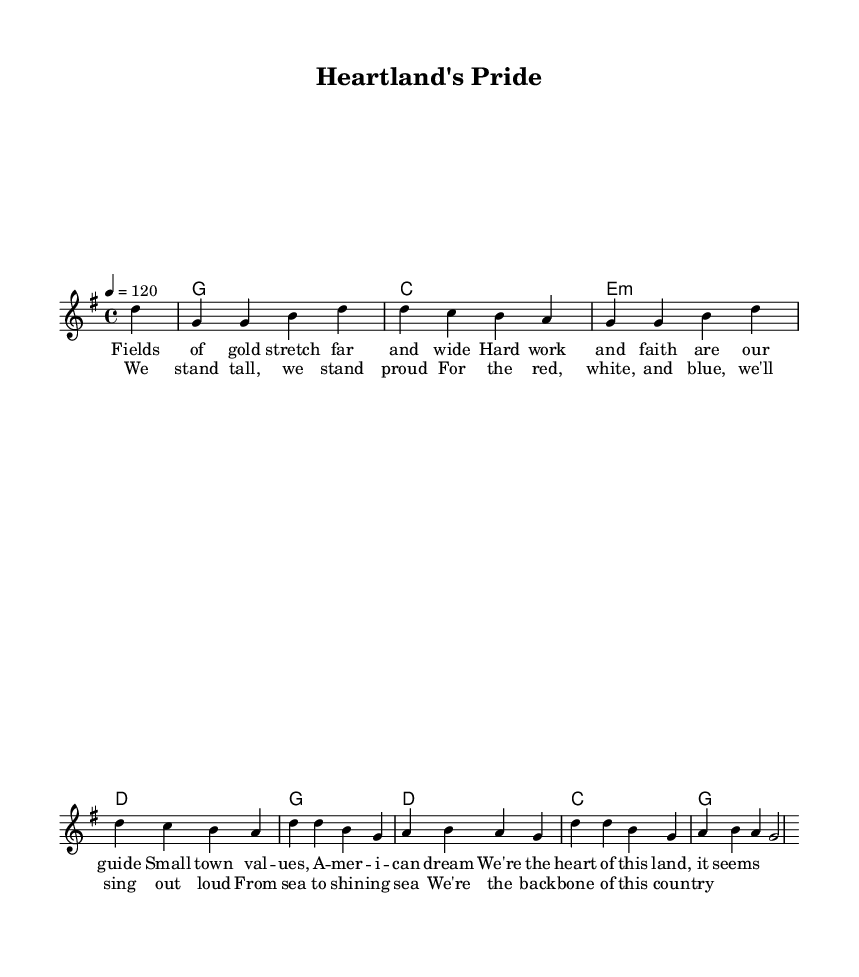What is the key signature of this music? The key signature displayed in the music is G major, which contains one sharp (F#). This is indicated at the beginning of the staff with a sign showing the sharp.
Answer: G major What is the time signature of this piece? The time signature is indicated at the beginning of the score as 4/4, meaning there are four beats per measure, and the quarter note receives one beat.
Answer: 4/4 What is the tempo marking for this song? The tempo marking is shown as 4 = 120, indicating that there are 120 quarter note beats per minute, leading to a moderately fast pace.
Answer: 120 How many measures are in the verse section of this piece? Counting each group of notes and the separation of lyrics, there are a total of 4 measures in the verse section of the music.
Answer: 4 What is the first lyric line in the chorus? The first line of lyrics in the chorus is located after the word "chorus," showing the text that follows it. That line reads: "We stand tall, we stand proud".
Answer: We stand tall, we stand proud Which chord accompanies the first measure of the melody? The first measure of the melody is accompanied by the chord G, which is indicated in the chord mode section of the score.
Answer: G What values do the lyrics emphasize in the verse? The lyrics emphasize values such as hard work, faith, and small-town values, highlighting the essence of rural American pride as expressed in the lyrics.
Answer: Hard work and faith 